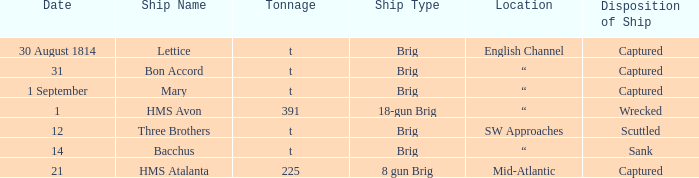The ship named Bacchus with a tonnage of t had what disposition of ship? Sank. 